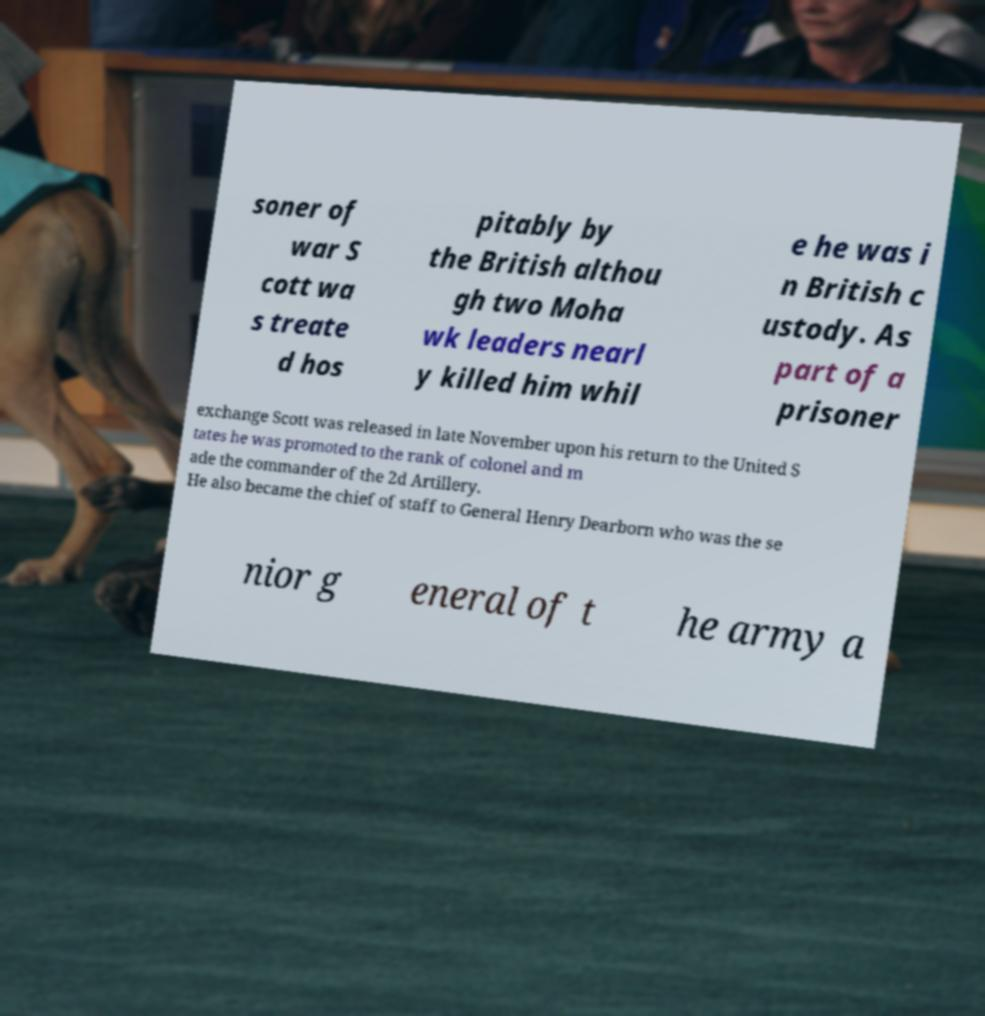What messages or text are displayed in this image? I need them in a readable, typed format. soner of war S cott wa s treate d hos pitably by the British althou gh two Moha wk leaders nearl y killed him whil e he was i n British c ustody. As part of a prisoner exchange Scott was released in late November upon his return to the United S tates he was promoted to the rank of colonel and m ade the commander of the 2d Artillery. He also became the chief of staff to General Henry Dearborn who was the se nior g eneral of t he army a 